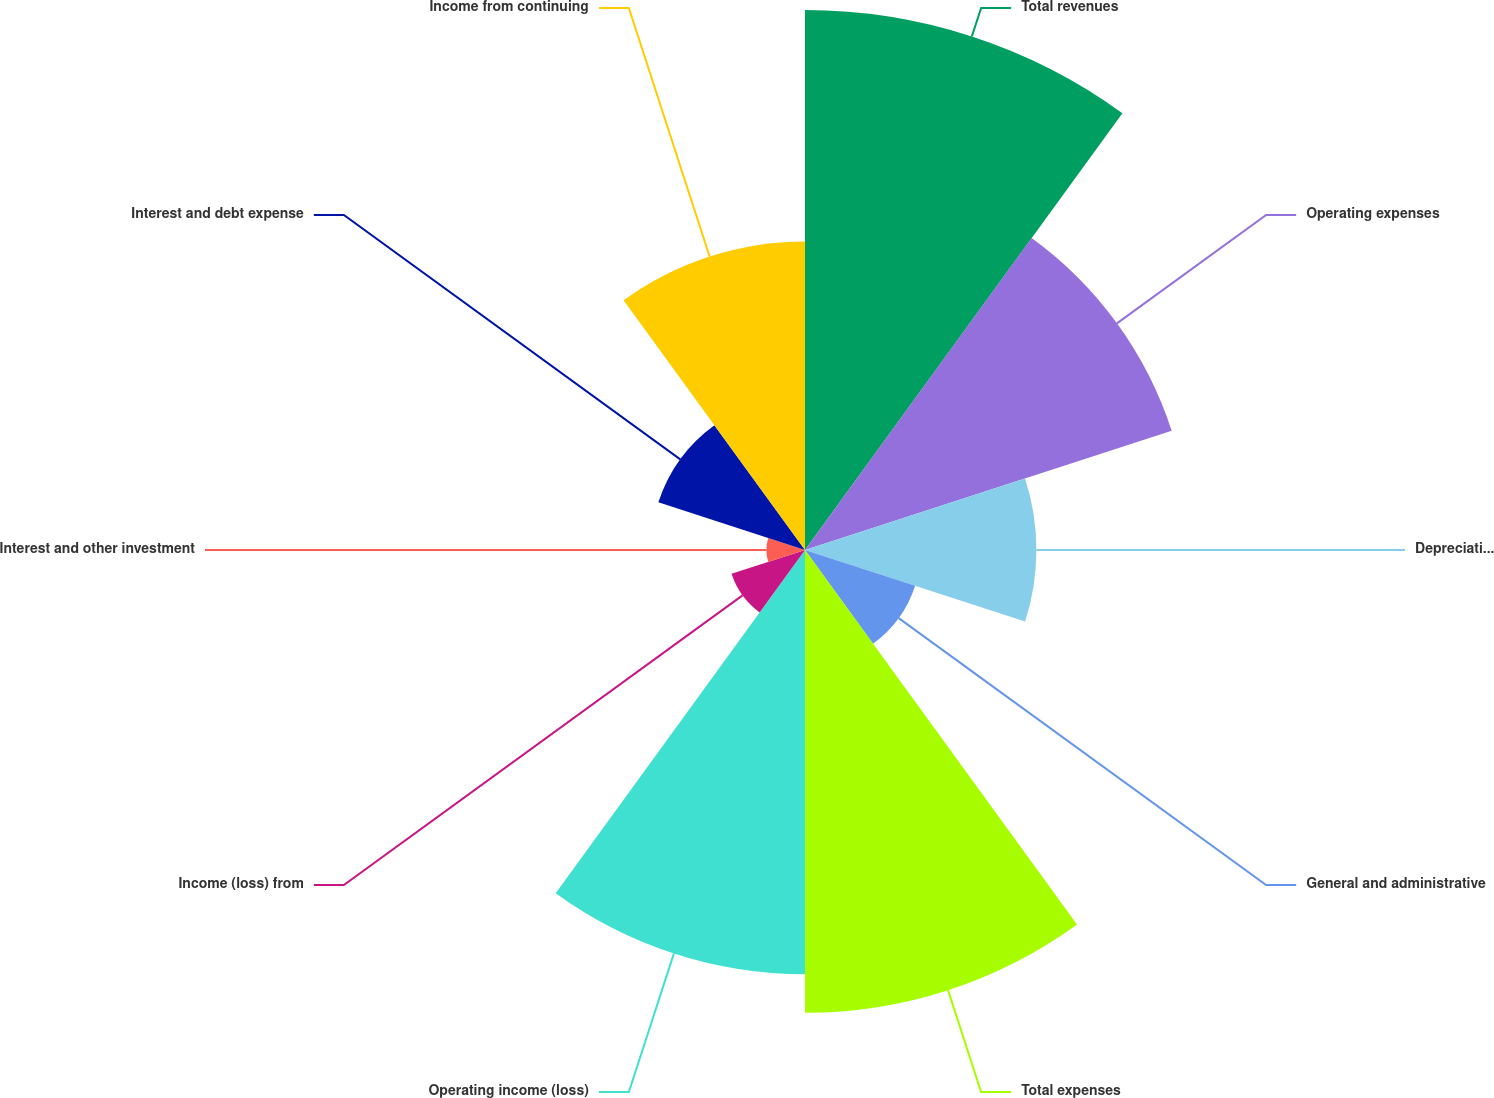<chart> <loc_0><loc_0><loc_500><loc_500><pie_chart><fcel>Total revenues<fcel>Operating expenses<fcel>Depreciation and amortization<fcel>General and administrative<fcel>Total expenses<fcel>Operating income (loss)<fcel>Income (loss) from<fcel>Interest and other investment<fcel>Interest and debt expense<fcel>Income from continuing<nl><fcel>19.72%<fcel>14.08%<fcel>8.45%<fcel>4.23%<fcel>16.9%<fcel>15.49%<fcel>2.82%<fcel>1.41%<fcel>5.63%<fcel>11.27%<nl></chart> 